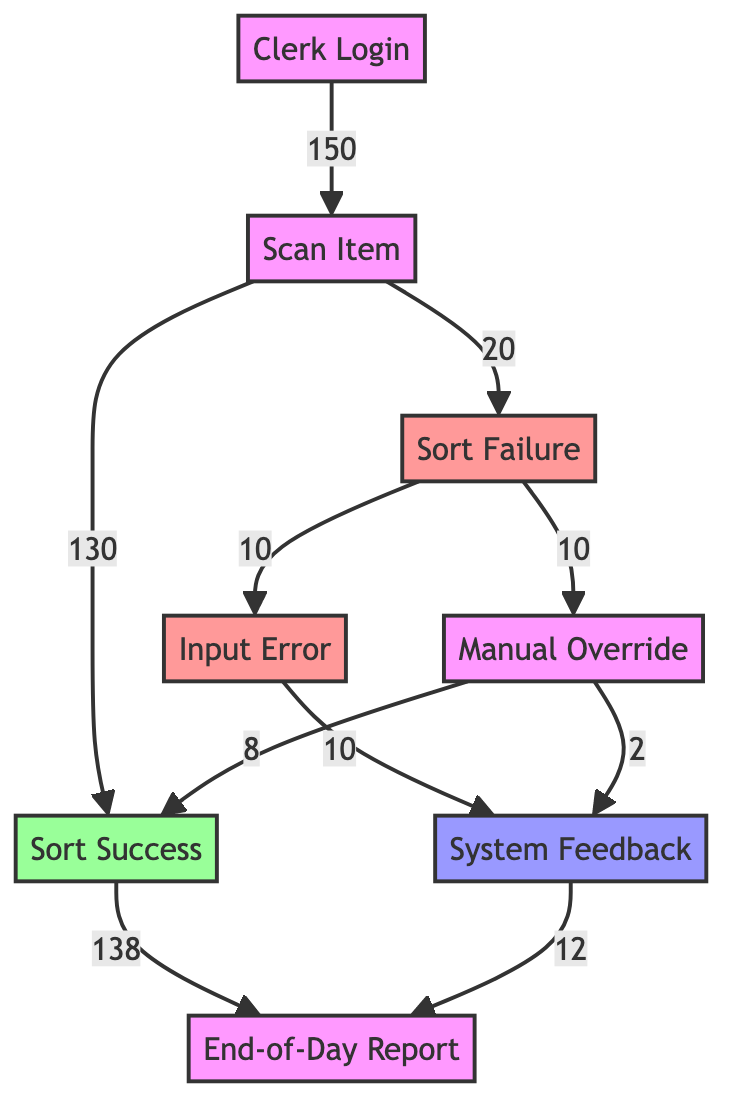What is the total number of interactions starting from Clerk Login? The diagram shows that the flow begins with the Clerk Login node. There are 150 interactions that proceed from this node to the Scan Item node, which indicates that the total number of interactions starting from Clerk Login is 150.
Answer: 150 How many sort failures occur during the scanning process? From the Scan Item node, there are two outcomes: Sort Success with 130 interactions and Sort Failure with 20 interactions. Therefore, the number of sort failures during the scanning process is 20.
Answer: 20 What percentage of scanned items are successfully sorted? To find this percentage, divide the number of Sort Success interactions (130) by the total number of scanned items (150). Multiply by 100 to convert to a percentage: (130/150) * 100 = 86.67%.
Answer: 86.67% How many manual overrides lead to successful sorting? The diagram indicates that there are 8 interactions from the Manual Override node that lead to Sort Success. Therefore, the number of manual overrides that lead to successful sorting is 8.
Answer: 8 What happens to the sort failures after inputting an error? From the Sort Failure node, there are two paths: 10 interactions lead to Input Error and 10 interactions lead to Manual Override. Thus, after inputting an error, the sort failures are directed towards the Input Error or Manual Override.
Answer: Input Error and Manual Override What is the total number of successful sorting interactions at the end of the day? From the Sort Success node, 138 interactions flow towards the End-of-Day Report node. Additionally, there are 12 interactions from the System Feedback node also leading to End-of-Day Report. Adding these gives a total of 150 successful sorting interactions: 138 + 12 = 150.
Answer: 150 What proportion of manual overrides results in system feedback? From the Manual Override node, there are 2 interactions that lead to System Feedback. The total manual overrides are 10 (8 successful and 2 feedback). Therefore, the proportion of manual overrides that results in system feedback is (2/10) = 0.2 or 20%.
Answer: 20% Which node has the highest number of outgoing interactions? Analyzing the outgoing interactions, the Sort Success node flows into End-of-Day Report with 138 interactions, which is the highest compared to the other nodes.
Answer: Sort Success What node has the least outgoing interactions? Looking at the nodes, both Manual Override and Input Error lead to 2 and 10 outgoing interactions respectively, but Manual Override has the least as it leads to only 2 interactions directing towards System Feedback.
Answer: Manual Override What flow percentage is associated with manual overrides leading to system feedback? There are 2 manual overrides leading to system feedback out of a total of 20 sort failures, which gives: (2/20) * 100 = 10%. Thus, the flow percentage associated is 10%.
Answer: 10% 